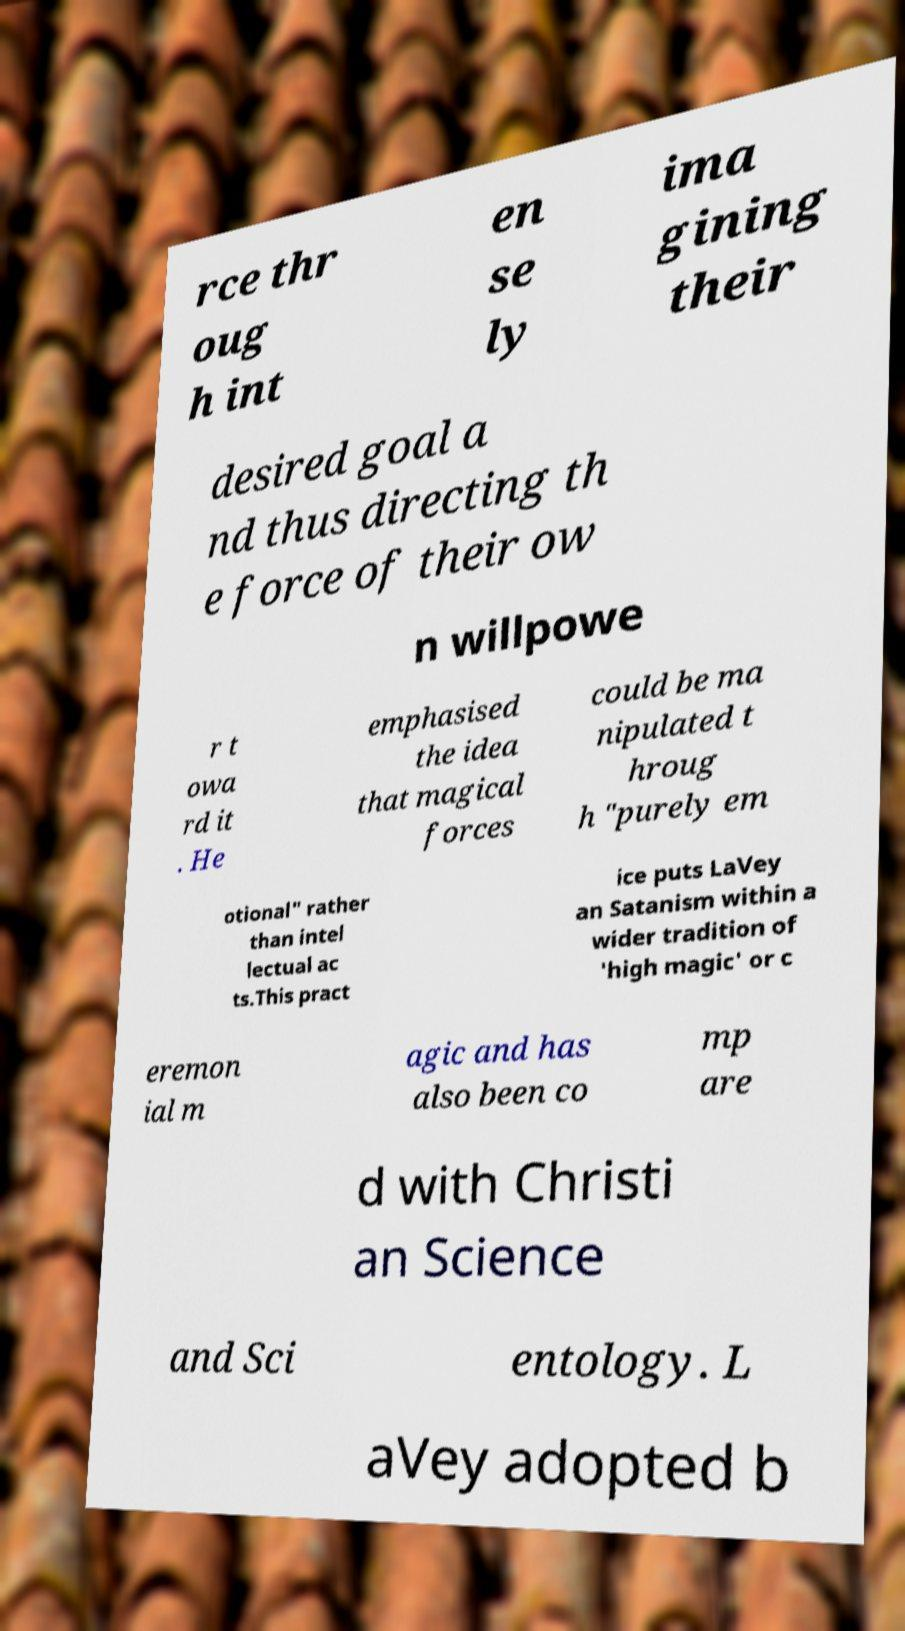What messages or text are displayed in this image? I need them in a readable, typed format. rce thr oug h int en se ly ima gining their desired goal a nd thus directing th e force of their ow n willpowe r t owa rd it . He emphasised the idea that magical forces could be ma nipulated t hroug h "purely em otional" rather than intel lectual ac ts.This pract ice puts LaVey an Satanism within a wider tradition of 'high magic' or c eremon ial m agic and has also been co mp are d with Christi an Science and Sci entology. L aVey adopted b 